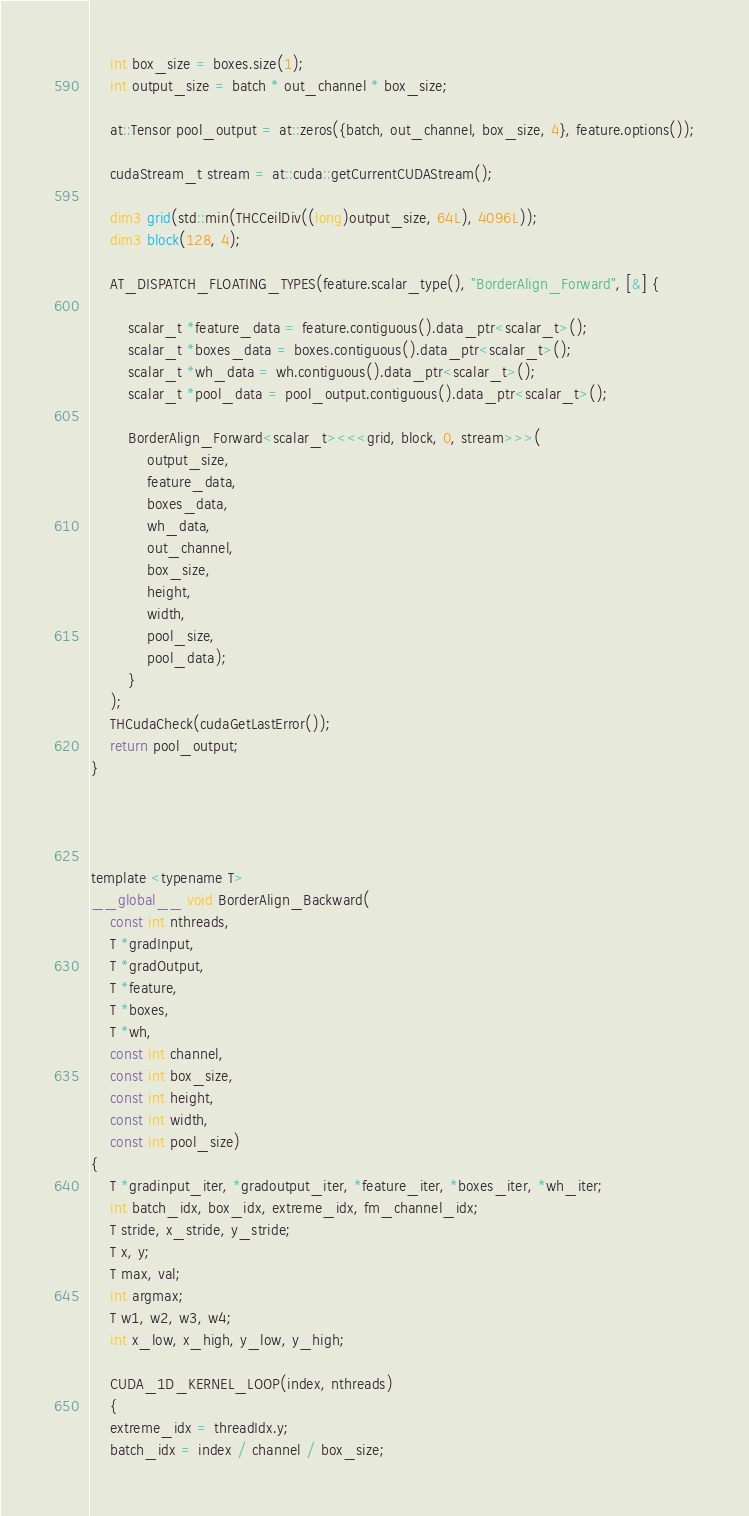<code> <loc_0><loc_0><loc_500><loc_500><_Cuda_>    int box_size = boxes.size(1);
    int output_size = batch * out_channel * box_size;

    at::Tensor pool_output = at::zeros({batch, out_channel, box_size, 4}, feature.options());

    cudaStream_t stream = at::cuda::getCurrentCUDAStream();

    dim3 grid(std::min(THCCeilDiv((long)output_size, 64L), 4096L));
    dim3 block(128, 4);

    AT_DISPATCH_FLOATING_TYPES(feature.scalar_type(), "BorderAlign_Forward", [&] {

        scalar_t *feature_data = feature.contiguous().data_ptr<scalar_t>();
        scalar_t *boxes_data = boxes.contiguous().data_ptr<scalar_t>();
        scalar_t *wh_data = wh.contiguous().data_ptr<scalar_t>();
        scalar_t *pool_data = pool_output.contiguous().data_ptr<scalar_t>();

        BorderAlign_Forward<scalar_t><<<grid, block, 0, stream>>>(
            output_size,
            feature_data,
            boxes_data,
            wh_data,
            out_channel,
            box_size,
            height,
            width,
            pool_size,
            pool_data);
        }
    );
    THCudaCheck(cudaGetLastError());
    return pool_output;
}




template <typename T>
__global__ void BorderAlign_Backward(
    const int nthreads,
    T *gradInput,
    T *gradOutput,
    T *feature,
    T *boxes,
    T *wh,
    const int channel,
    const int box_size,
    const int height,
    const int width,
    const int pool_size)
{
    T *gradinput_iter, *gradoutput_iter, *feature_iter, *boxes_iter, *wh_iter;
    int batch_idx, box_idx, extreme_idx, fm_channel_idx;
    T stride, x_stride, y_stride;
    T x, y;
    T max, val;
    int argmax;
    T w1, w2, w3, w4;
    int x_low, x_high, y_low, y_high;

    CUDA_1D_KERNEL_LOOP(index, nthreads)
    {
    extreme_idx = threadIdx.y;
    batch_idx = index / channel / box_size;</code> 